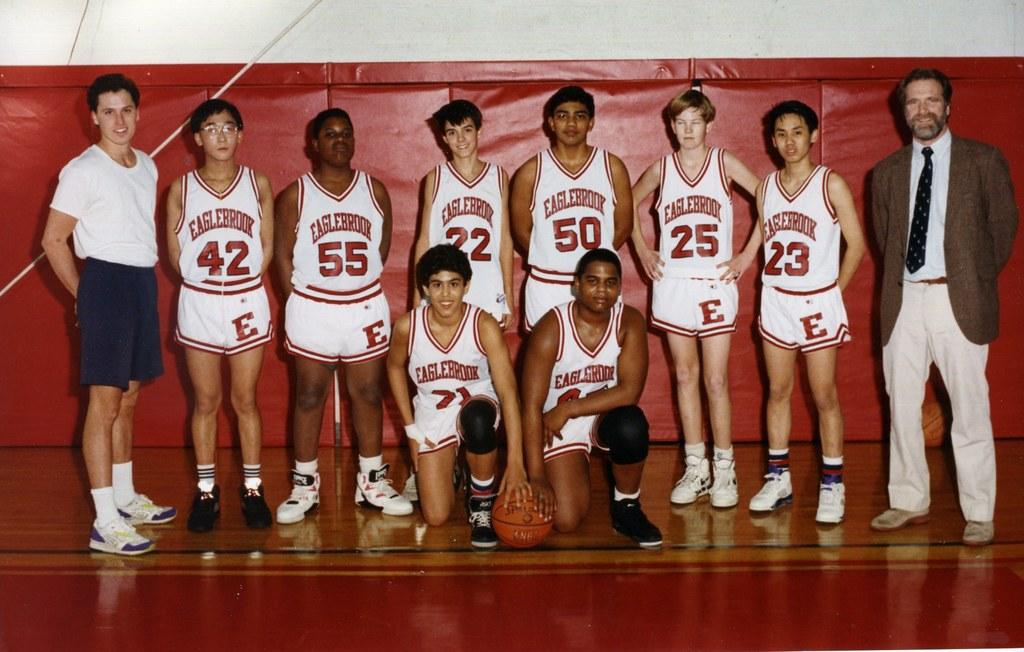What is the name of the basketball team?
Provide a succinct answer. Eaglebrook. What number is between 23 and 50?
Provide a short and direct response. 25. 